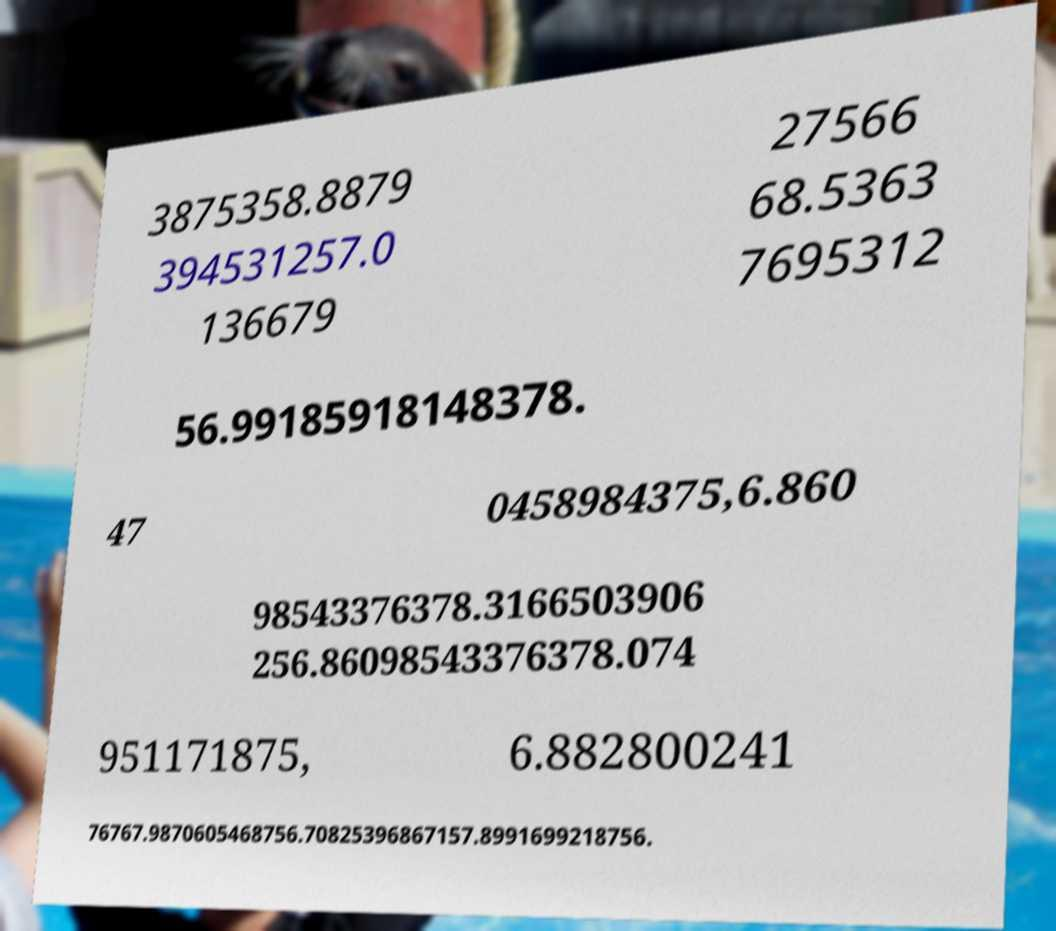For documentation purposes, I need the text within this image transcribed. Could you provide that? 3875358.8879 394531257.0 136679 27566 68.5363 7695312 56.99185918148378. 47 0458984375,6.860 98543376378.3166503906 256.86098543376378.074 951171875, 6.882800241 76767.9870605468756.70825396867157.8991699218756. 